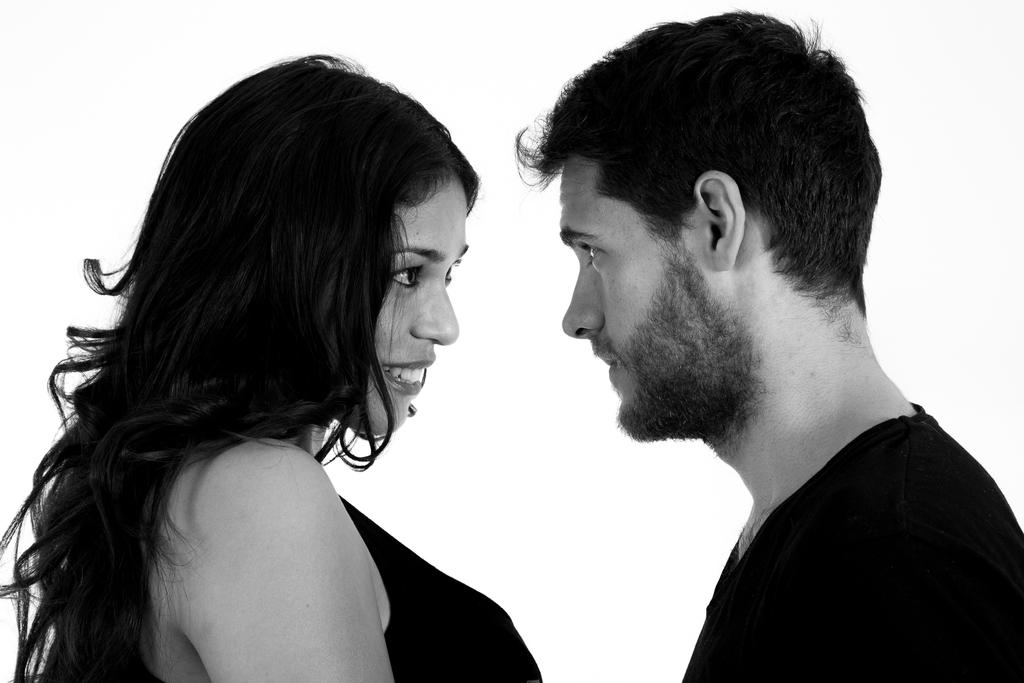Who is present in the image? There is a woman and a man in the image. What is the woman doing in the image? The woman is smiling in the image. How are the man and the woman interacting in the image? The man and the woman are looking at each other in the image. What is the color of the background in the image? The background of the image is white. How many babies are crawling on the floor in the image? There are no babies present in the image; it features a woman and a man looking at each other. Is there a lamp visible in the image? There is no lamp present in the image. 